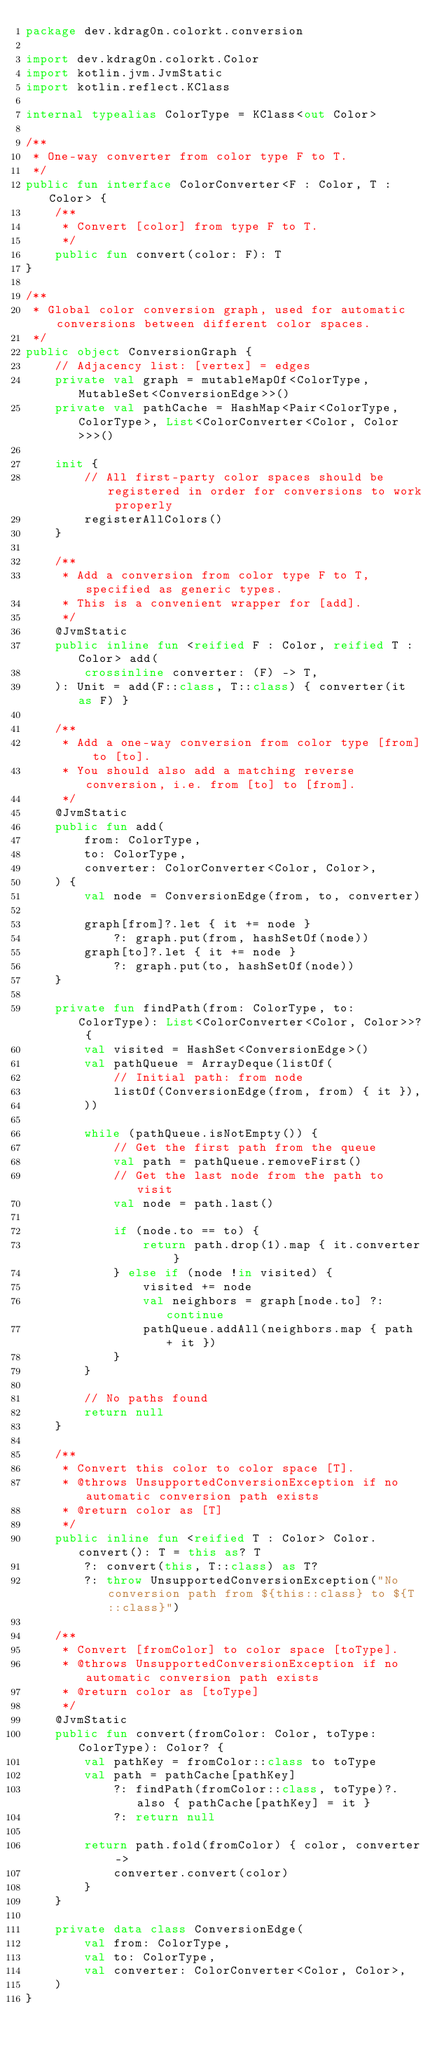<code> <loc_0><loc_0><loc_500><loc_500><_Kotlin_>package dev.kdrag0n.colorkt.conversion

import dev.kdrag0n.colorkt.Color
import kotlin.jvm.JvmStatic
import kotlin.reflect.KClass

internal typealias ColorType = KClass<out Color>

/**
 * One-way converter from color type F to T.
 */
public fun interface ColorConverter<F : Color, T : Color> {
    /**
     * Convert [color] from type F to T.
     */
    public fun convert(color: F): T
}

/**
 * Global color conversion graph, used for automatic conversions between different color spaces.
 */
public object ConversionGraph {
    // Adjacency list: [vertex] = edges
    private val graph = mutableMapOf<ColorType, MutableSet<ConversionEdge>>()
    private val pathCache = HashMap<Pair<ColorType, ColorType>, List<ColorConverter<Color, Color>>>()

    init {
        // All first-party color spaces should be registered in order for conversions to work properly
        registerAllColors()
    }

    /**
     * Add a conversion from color type F to T, specified as generic types.
     * This is a convenient wrapper for [add].
     */
    @JvmStatic
    public inline fun <reified F : Color, reified T : Color> add(
        crossinline converter: (F) -> T,
    ): Unit = add(F::class, T::class) { converter(it as F) }

    /**
     * Add a one-way conversion from color type [from] to [to].
     * You should also add a matching reverse conversion, i.e. from [to] to [from].
     */
    @JvmStatic
    public fun add(
        from: ColorType,
        to: ColorType,
        converter: ColorConverter<Color, Color>,
    ) {
        val node = ConversionEdge(from, to, converter)

        graph[from]?.let { it += node }
            ?: graph.put(from, hashSetOf(node))
        graph[to]?.let { it += node }
            ?: graph.put(to, hashSetOf(node))
    }

    private fun findPath(from: ColorType, to: ColorType): List<ColorConverter<Color, Color>>? {
        val visited = HashSet<ConversionEdge>()
        val pathQueue = ArrayDeque(listOf(
            // Initial path: from node
            listOf(ConversionEdge(from, from) { it }),
        ))

        while (pathQueue.isNotEmpty()) {
            // Get the first path from the queue
            val path = pathQueue.removeFirst()
            // Get the last node from the path to visit
            val node = path.last()

            if (node.to == to) {
                return path.drop(1).map { it.converter }
            } else if (node !in visited) {
                visited += node
                val neighbors = graph[node.to] ?: continue
                pathQueue.addAll(neighbors.map { path + it })
            }
        }

        // No paths found
        return null
    }

    /**
     * Convert this color to color space [T].
     * @throws UnsupportedConversionException if no automatic conversion path exists
     * @return color as [T]
     */
    public inline fun <reified T : Color> Color.convert(): T = this as? T
        ?: convert(this, T::class) as T?
        ?: throw UnsupportedConversionException("No conversion path from ${this::class} to ${T::class}")

    /**
     * Convert [fromColor] to color space [toType].
     * @throws UnsupportedConversionException if no automatic conversion path exists
     * @return color as [toType]
     */
    @JvmStatic
    public fun convert(fromColor: Color, toType: ColorType): Color? {
        val pathKey = fromColor::class to toType
        val path = pathCache[pathKey]
            ?: findPath(fromColor::class, toType)?.also { pathCache[pathKey] = it }
            ?: return null

        return path.fold(fromColor) { color, converter ->
            converter.convert(color)
        }
    }

    private data class ConversionEdge(
        val from: ColorType,
        val to: ColorType,
        val converter: ColorConverter<Color, Color>,
    )
}
</code> 